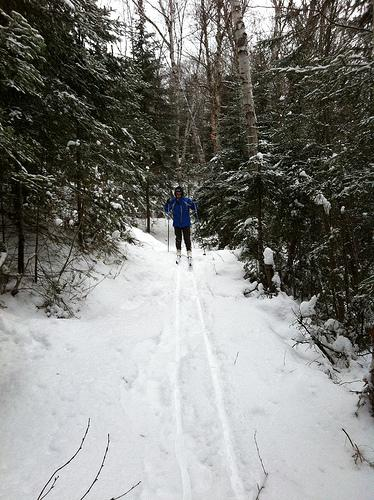Question: why is the person there?
Choices:
A. Sledding.
B. Snowboarding.
C. Ice skating.
D. Skiing.
Answer with the letter. Answer: D Question: who is with the person?
Choices:
A. No one.
B. 1 man.
C. 1 woman.
D. 2 kids.
Answer with the letter. Answer: A Question: what is the person wearing?
Choices:
A. Mittens.
B. Ski suit.
C. Wool hat.
D. Goggles.
Answer with the letter. Answer: B 